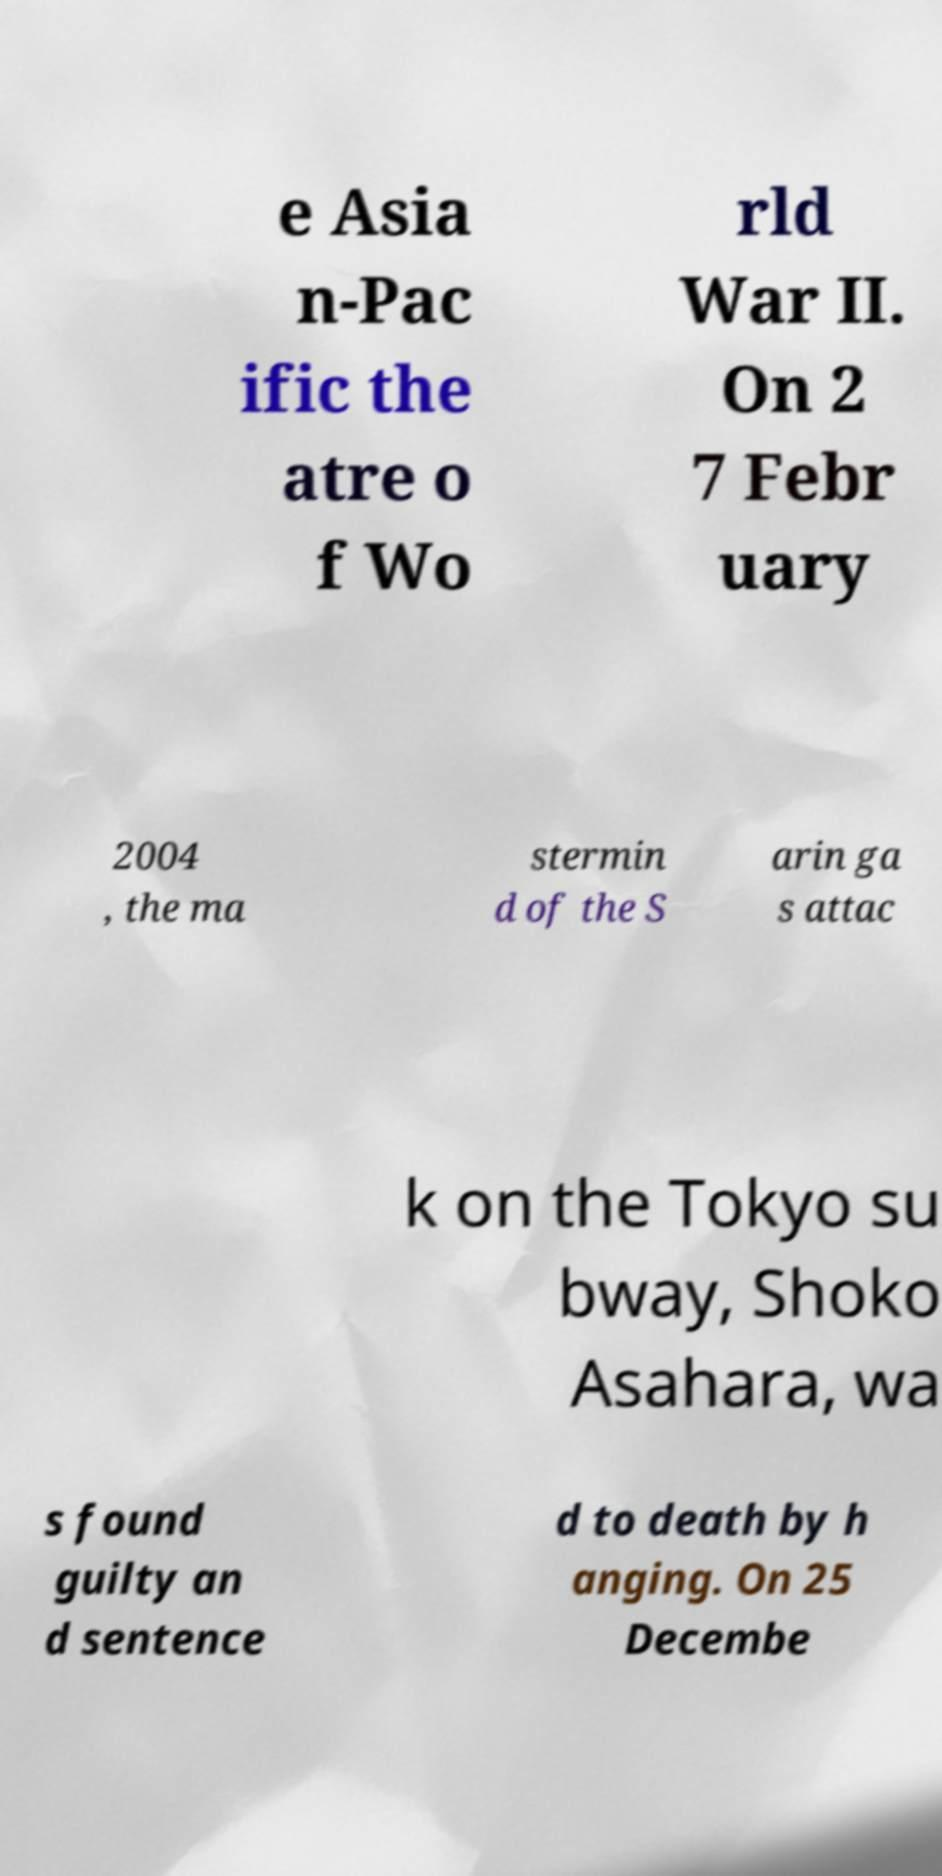I need the written content from this picture converted into text. Can you do that? e Asia n-Pac ific the atre o f Wo rld War II. On 2 7 Febr uary 2004 , the ma stermin d of the S arin ga s attac k on the Tokyo su bway, Shoko Asahara, wa s found guilty an d sentence d to death by h anging. On 25 Decembe 